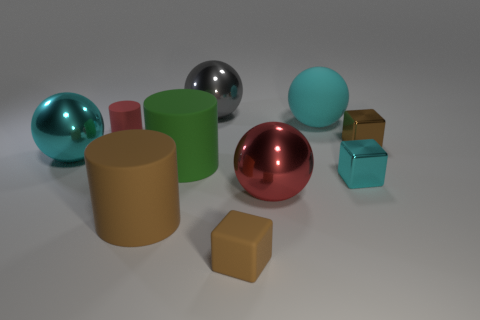Subtract all tiny shiny blocks. How many blocks are left? 1 Subtract all spheres. How many objects are left? 6 Subtract 4 spheres. How many spheres are left? 0 Subtract all cyan blocks. Subtract all green spheres. How many blocks are left? 2 Subtract all blue blocks. How many green cylinders are left? 1 Subtract all gray things. Subtract all small cylinders. How many objects are left? 8 Add 4 rubber things. How many rubber things are left? 9 Add 2 small shiny objects. How many small shiny objects exist? 4 Subtract all green cylinders. How many cylinders are left? 2 Subtract 0 blue cubes. How many objects are left? 10 